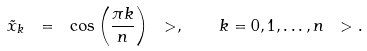Convert formula to latex. <formula><loc_0><loc_0><loc_500><loc_500>\tilde { x } _ { k } \ = \ \cos \left ( \frac { \pi k } { n } \right ) \ > , \quad k = 0 , 1 , \dots , n \ > .</formula> 